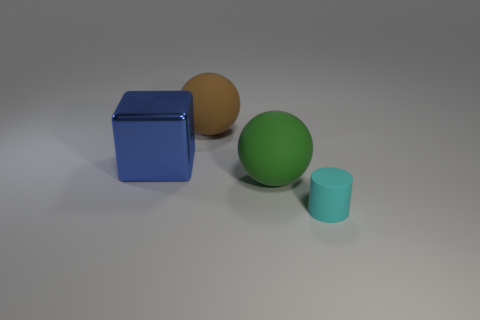Is there anything else that is the same material as the blue cube?
Make the answer very short. No. There is a rubber thing that is to the right of the green thing; is its shape the same as the large brown thing?
Your response must be concise. No. What is the color of the small thing that is made of the same material as the large green thing?
Offer a very short reply. Cyan. Are there any cyan cylinders that are to the right of the ball that is in front of the object to the left of the brown matte ball?
Offer a very short reply. Yes. There is a cyan matte thing; what shape is it?
Ensure brevity in your answer.  Cylinder. Is the number of cubes to the right of the small cylinder less than the number of big brown things?
Offer a very short reply. Yes. Is there a green object of the same shape as the brown rubber thing?
Your answer should be very brief. Yes. What is the shape of the green matte object that is the same size as the metallic object?
Provide a short and direct response. Sphere. What number of things are large purple things or big objects?
Your response must be concise. 3. Are there any small cyan matte cylinders?
Your answer should be very brief. Yes. 